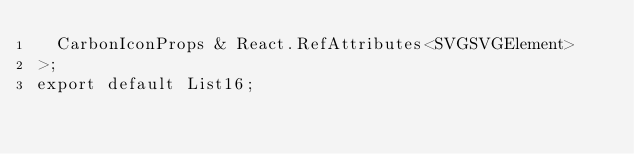Convert code to text. <code><loc_0><loc_0><loc_500><loc_500><_TypeScript_>  CarbonIconProps & React.RefAttributes<SVGSVGElement>
>;
export default List16;
</code> 